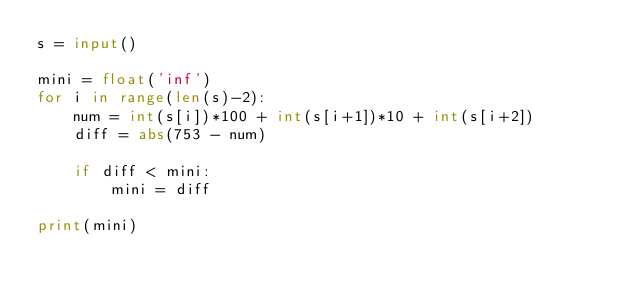<code> <loc_0><loc_0><loc_500><loc_500><_Python_>s = input()

mini = float('inf')
for i in range(len(s)-2):
    num = int(s[i])*100 + int(s[i+1])*10 + int(s[i+2])
    diff = abs(753 - num)

    if diff < mini:
        mini = diff

print(mini)</code> 